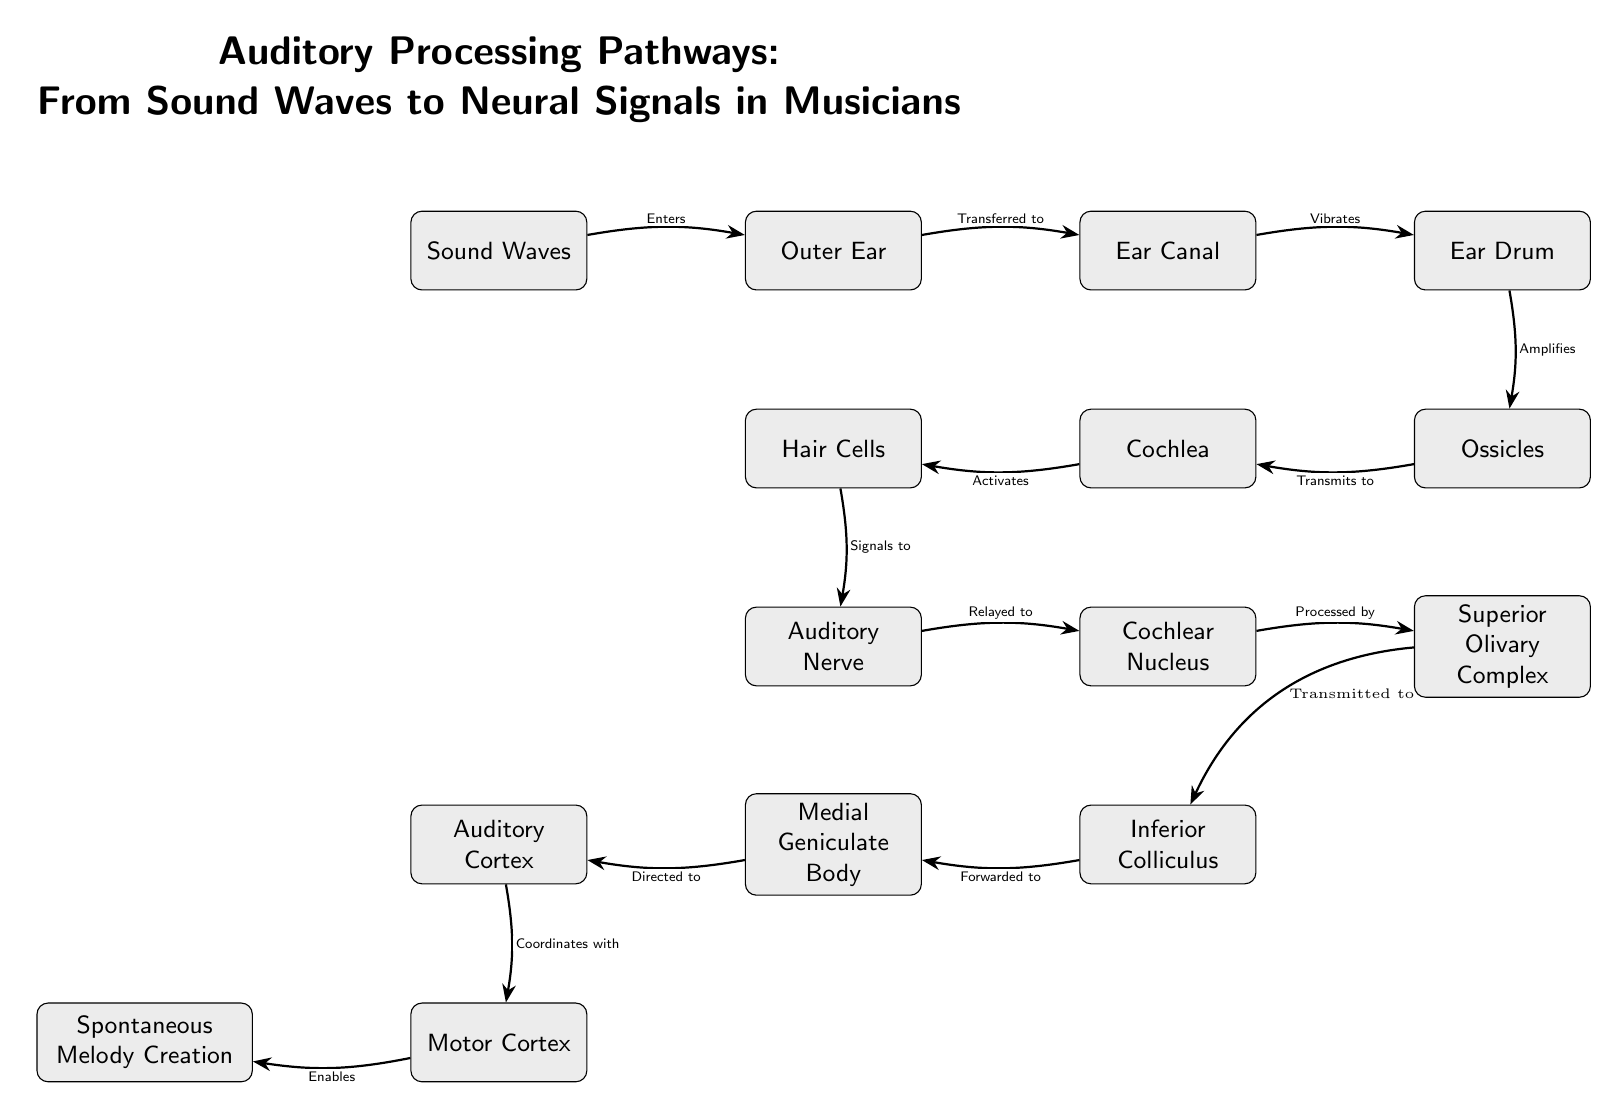What is the starting point of the auditory processing pathway? The starting point of the pathway is indicated by the first node, which is labeled "Sound Waves." This is where the auditory processing begins before moving through subsequent nodes.
Answer: Sound Waves How many nodes are in the auditory processing pathway? By counting the distinct boxes within the diagram, there are a total of 14 nodes that represent both anatomical structures and processes involved in auditory processing.
Answer: 14 What structure is directly connected to the "Hair Cells"? The "Hair Cells" node is connected to the "Cochlea," which is the structure that contains the hair cells responsible for converting sound vibrations into neural signals.
Answer: Cochlea What function does the "Audiory Cortex" serve in musical creation? The "Auditory Cortex" is stated to "Coordinates with" the "Motor Cortex," which implies its role in integrating sensory information with motor functions to facilitate actions like spontaneous melody creation.
Answer: Coordinates with Which node represents the initial amplification of sound? The "Ear Drum" is connected to the "Ossicles," where it performs the function of amplifying sound waves before they are transmitted to the inner ear structures.
Answer: Ear Drum What is the last step before creating a spontaneous melody? The last step indicated before "Spontaneous Melody Creation" is a connection from the "Motor Cortex," which suggests that the motor functions influenced by auditory processing enable this creative action.
Answer: Motor Cortex Which structure does the "Auditory Nerve" signal to next? The "Auditory Nerve" sends signals to the "Cochlear Nucleus," where auditory processing continues. This step involves relaying the signals for further processing.
Answer: Cochlear Nucleus What is the relationship between the "Inferior Colliculus" and the "Medial Geniculate Body"? The "Inferior Colliculus" sends signals that are "Forwarded to" the "Medial Geniculate Body," indicating a sequential processing step in auditory pathways.
Answer: Forwarded to What kind of signals do "Hair Cells" produce? The "Hair Cells" produce signals that are relayed to the "Auditory Nerve," indicating their role in transducing mechanical sound waves into neural signals for further processing.
Answer: Signals to 